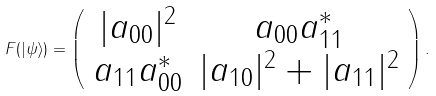<formula> <loc_0><loc_0><loc_500><loc_500>F ( | \psi \rangle ) = \left ( \begin{array} { c c } | a _ { 0 0 } | ^ { 2 } & a _ { 0 0 } a _ { 1 1 } ^ { \ast } \\ a _ { 1 1 } a _ { 0 0 } ^ { \ast } & | a _ { 1 0 } | ^ { 2 } + | a _ { 1 1 } | ^ { 2 } \end{array} \right ) .</formula> 